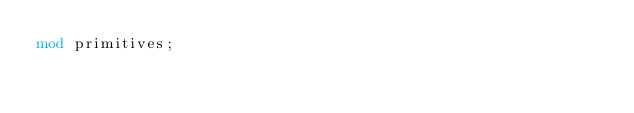<code> <loc_0><loc_0><loc_500><loc_500><_Rust_>mod primitives;
</code> 